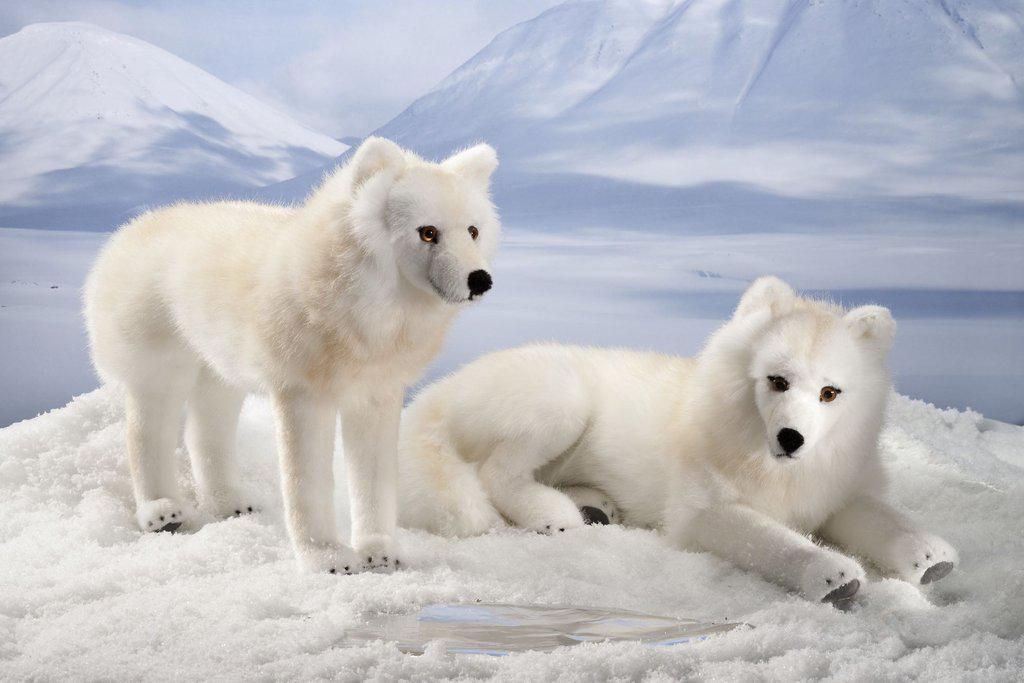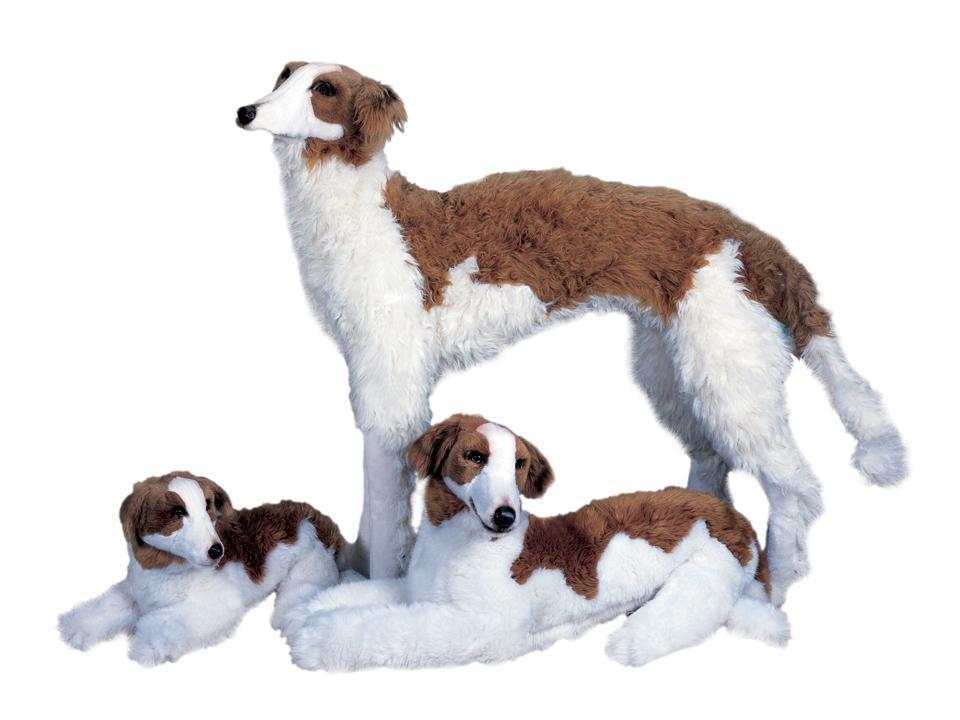The first image is the image on the left, the second image is the image on the right. For the images shown, is this caption "One of the two dogs in the image on the left is standing while the other is lying down." true? Answer yes or no. Yes. The first image is the image on the left, the second image is the image on the right. Examine the images to the left and right. Is the description "One image shows a trio of dogs, with two reclining next to a standing dog." accurate? Answer yes or no. Yes. 